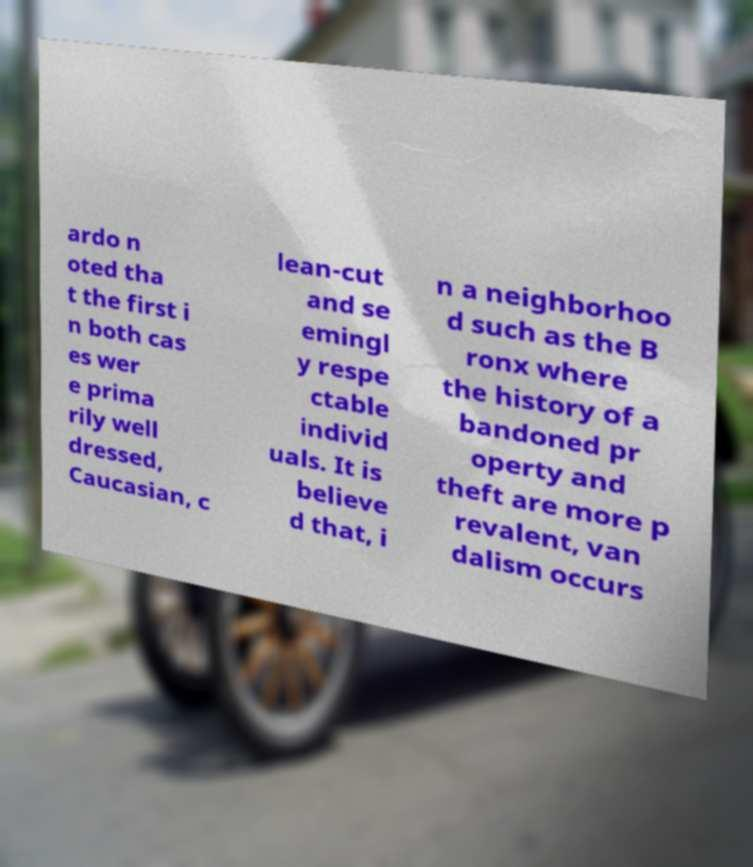What messages or text are displayed in this image? I need them in a readable, typed format. ardo n oted tha t the first i n both cas es wer e prima rily well dressed, Caucasian, c lean-cut and se emingl y respe ctable individ uals. It is believe d that, i n a neighborhoo d such as the B ronx where the history of a bandoned pr operty and theft are more p revalent, van dalism occurs 